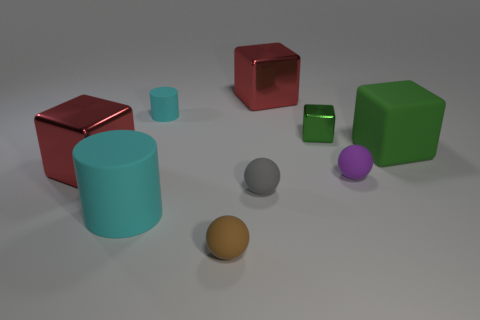There is a large red thing behind the green block that is in front of the small green metallic block; what shape is it?
Provide a succinct answer. Cube. What number of other objects are there of the same shape as the small brown rubber object?
Offer a terse response. 2. There is a small cyan matte thing; are there any tiny cyan things to the right of it?
Ensure brevity in your answer.  No. The tiny cube is what color?
Offer a terse response. Green. Is the color of the matte block the same as the large matte object that is in front of the purple matte thing?
Your answer should be compact. No. Is there a brown ball that has the same size as the brown rubber thing?
Make the answer very short. No. There is another rubber cylinder that is the same color as the large rubber cylinder; what is its size?
Ensure brevity in your answer.  Small. There is a thing that is to the left of the large cylinder; what is its material?
Offer a very short reply. Metal. Are there the same number of tiny cubes on the left side of the gray matte ball and purple rubber things left of the brown matte object?
Your answer should be very brief. Yes. Does the rubber cylinder that is on the left side of the small cylinder have the same size as the red metallic thing to the left of the small cyan object?
Provide a succinct answer. Yes. 